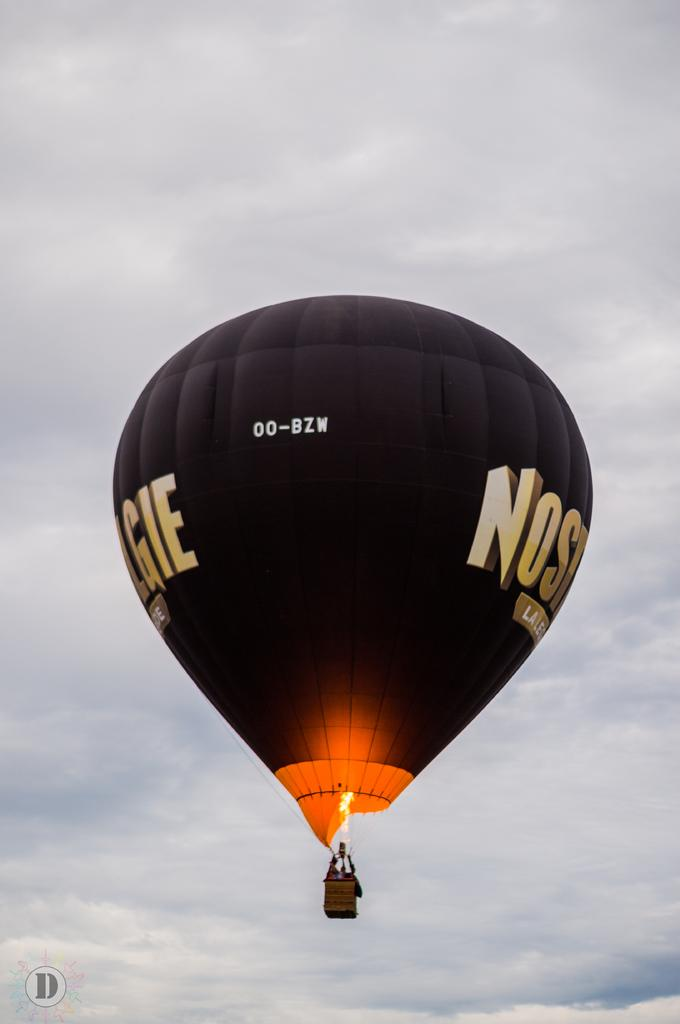<image>
Render a clear and concise summary of the photo. Hot air balloon that has the identifier 00-BZW and the letter NOS and GIE can be seen. 